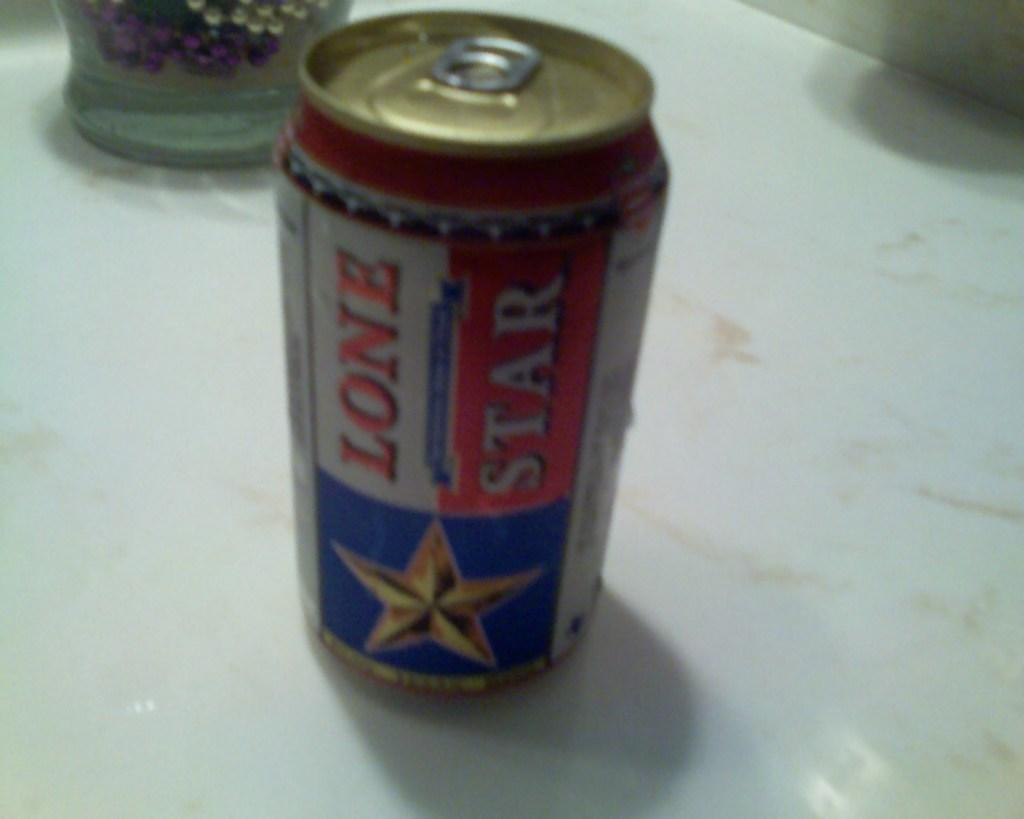<image>
Write a terse but informative summary of the picture. Out of focus lone star can on a white table. 